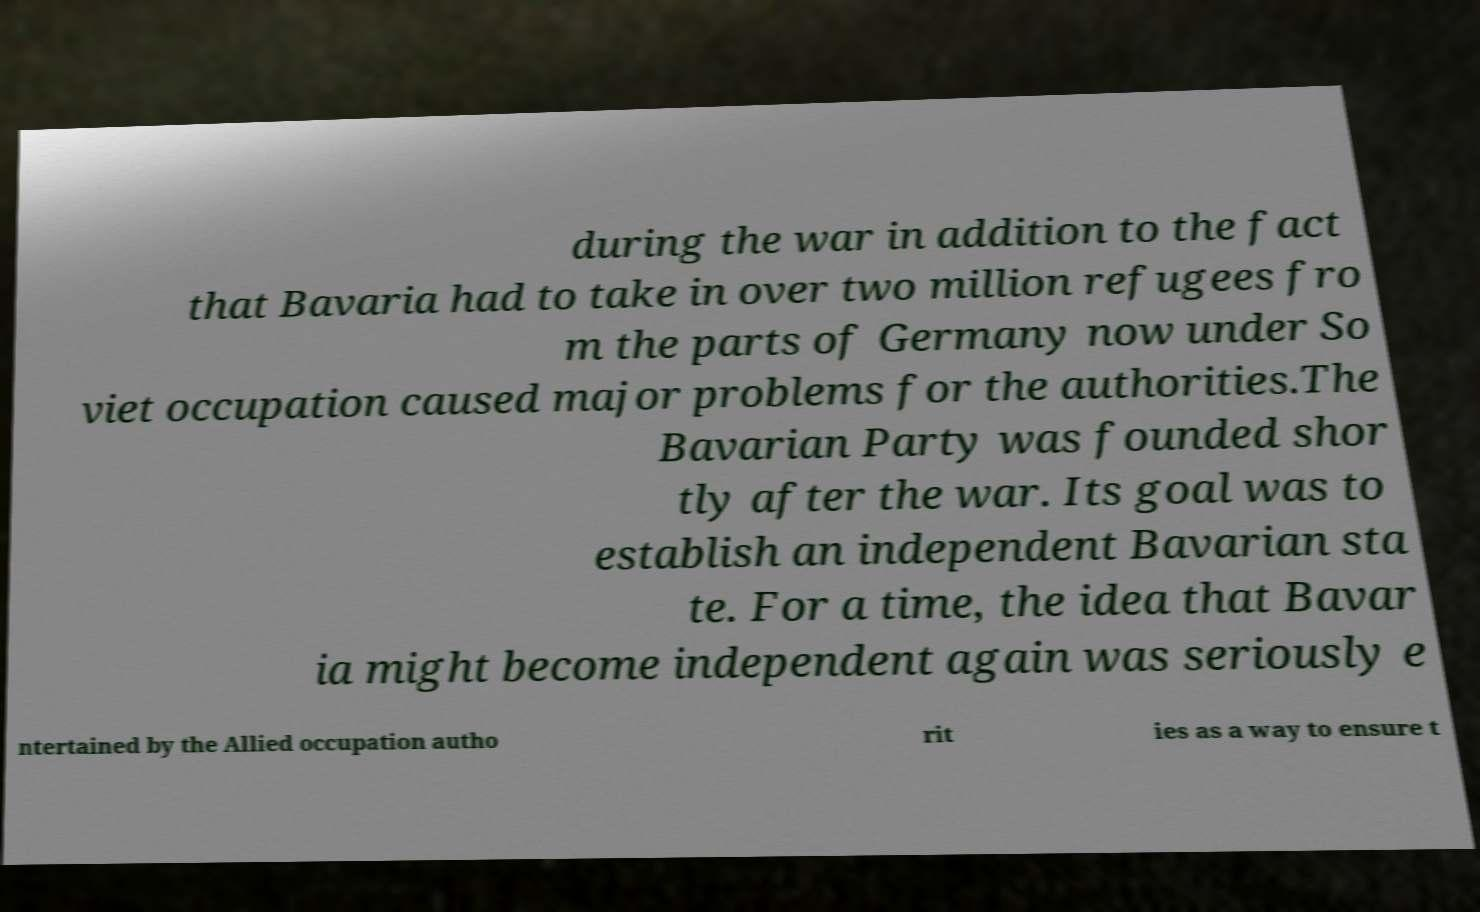What messages or text are displayed in this image? I need them in a readable, typed format. during the war in addition to the fact that Bavaria had to take in over two million refugees fro m the parts of Germany now under So viet occupation caused major problems for the authorities.The Bavarian Party was founded shor tly after the war. Its goal was to establish an independent Bavarian sta te. For a time, the idea that Bavar ia might become independent again was seriously e ntertained by the Allied occupation autho rit ies as a way to ensure t 